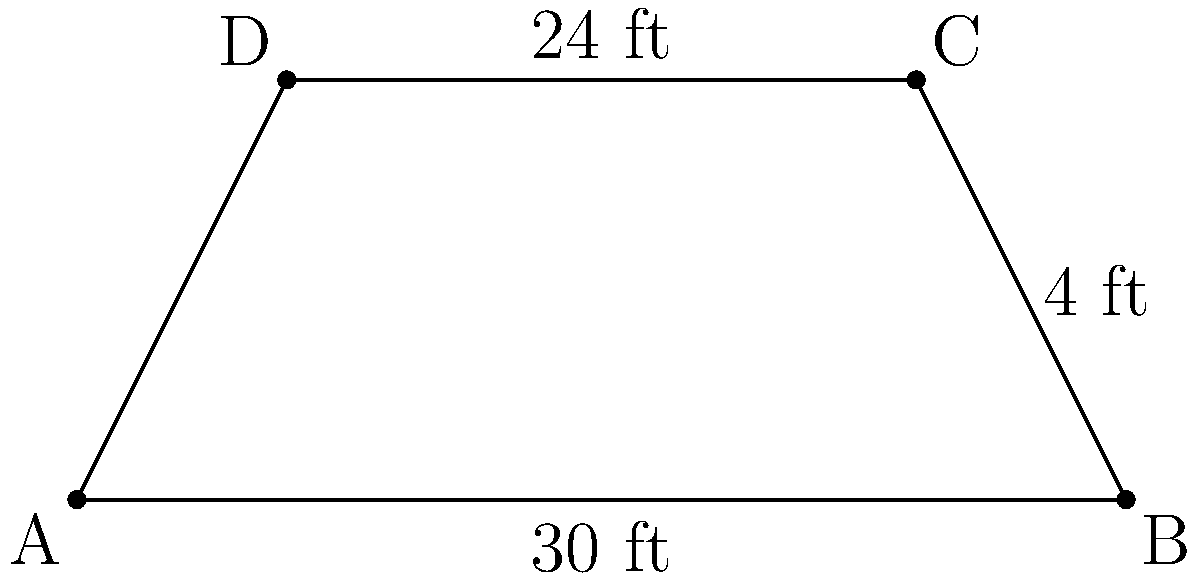As a VIP area designer for an upcoming hip-hop festival, you're tasked with creating a trapezoid-shaped section. The longer parallel side measures 30 feet, the shorter parallel side is 24 feet, and the height between them is 4 feet. What is the total area of this VIP section in square feet? To find the area of a trapezoid, we use the formula:

$$A = \frac{1}{2}(b_1 + b_2)h$$

Where:
$A$ = Area
$b_1$ = Length of one parallel side
$b_2$ = Length of the other parallel side
$h$ = Height (perpendicular distance between the parallel sides)

Given:
$b_1 = 30$ feet (longer side)
$b_2 = 24$ feet (shorter side)
$h = 4$ feet

Let's substitute these values into the formula:

$$A = \frac{1}{2}(30 + 24) \times 4$$

$$A = \frac{1}{2}(54) \times 4$$

$$A = 27 \times 4$$

$$A = 108$$

Therefore, the total area of the VIP section is 108 square feet.
Answer: 108 sq ft 